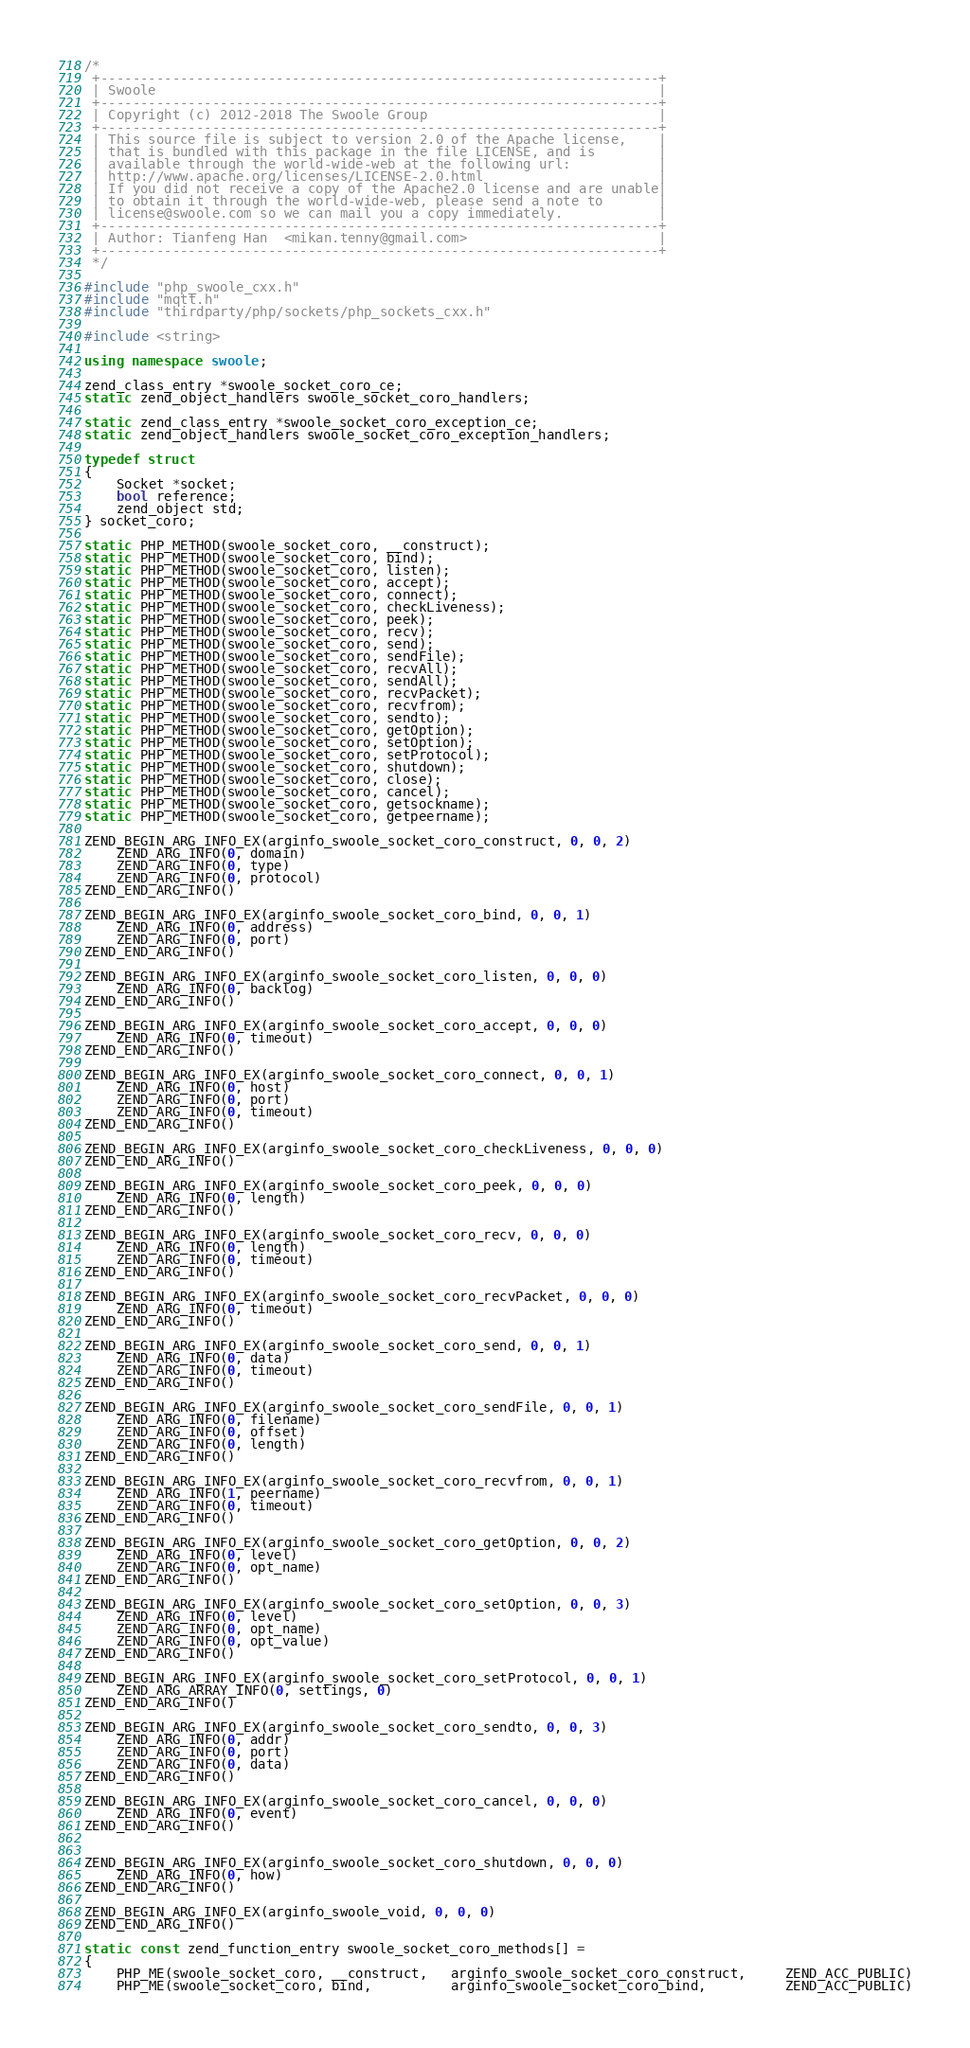<code> <loc_0><loc_0><loc_500><loc_500><_C++_>/*
 +----------------------------------------------------------------------+
 | Swoole                                                               |
 +----------------------------------------------------------------------+
 | Copyright (c) 2012-2018 The Swoole Group                             |
 +----------------------------------------------------------------------+
 | This source file is subject to version 2.0 of the Apache license,    |
 | that is bundled with this package in the file LICENSE, and is        |
 | available through the world-wide-web at the following url:           |
 | http://www.apache.org/licenses/LICENSE-2.0.html                      |
 | If you did not receive a copy of the Apache2.0 license and are unable|
 | to obtain it through the world-wide-web, please send a note to       |
 | license@swoole.com so we can mail you a copy immediately.            |
 +----------------------------------------------------------------------+
 | Author: Tianfeng Han  <mikan.tenny@gmail.com>                        |
 +----------------------------------------------------------------------+
 */

#include "php_swoole_cxx.h"
#include "mqtt.h"
#include "thirdparty/php/sockets/php_sockets_cxx.h"

#include <string>

using namespace swoole;

zend_class_entry *swoole_socket_coro_ce;
static zend_object_handlers swoole_socket_coro_handlers;

static zend_class_entry *swoole_socket_coro_exception_ce;
static zend_object_handlers swoole_socket_coro_exception_handlers;

typedef struct
{
    Socket *socket;
    bool reference;
    zend_object std;
} socket_coro;

static PHP_METHOD(swoole_socket_coro, __construct);
static PHP_METHOD(swoole_socket_coro, bind);
static PHP_METHOD(swoole_socket_coro, listen);
static PHP_METHOD(swoole_socket_coro, accept);
static PHP_METHOD(swoole_socket_coro, connect);
static PHP_METHOD(swoole_socket_coro, checkLiveness);
static PHP_METHOD(swoole_socket_coro, peek);
static PHP_METHOD(swoole_socket_coro, recv);
static PHP_METHOD(swoole_socket_coro, send);
static PHP_METHOD(swoole_socket_coro, sendFile);
static PHP_METHOD(swoole_socket_coro, recvAll);
static PHP_METHOD(swoole_socket_coro, sendAll);
static PHP_METHOD(swoole_socket_coro, recvPacket);
static PHP_METHOD(swoole_socket_coro, recvfrom);
static PHP_METHOD(swoole_socket_coro, sendto);
static PHP_METHOD(swoole_socket_coro, getOption);
static PHP_METHOD(swoole_socket_coro, setOption);
static PHP_METHOD(swoole_socket_coro, setProtocol);
static PHP_METHOD(swoole_socket_coro, shutdown);
static PHP_METHOD(swoole_socket_coro, close);
static PHP_METHOD(swoole_socket_coro, cancel);
static PHP_METHOD(swoole_socket_coro, getsockname);
static PHP_METHOD(swoole_socket_coro, getpeername);

ZEND_BEGIN_ARG_INFO_EX(arginfo_swoole_socket_coro_construct, 0, 0, 2)
    ZEND_ARG_INFO(0, domain)
    ZEND_ARG_INFO(0, type)
    ZEND_ARG_INFO(0, protocol)
ZEND_END_ARG_INFO()

ZEND_BEGIN_ARG_INFO_EX(arginfo_swoole_socket_coro_bind, 0, 0, 1)
    ZEND_ARG_INFO(0, address)
    ZEND_ARG_INFO(0, port)
ZEND_END_ARG_INFO()

ZEND_BEGIN_ARG_INFO_EX(arginfo_swoole_socket_coro_listen, 0, 0, 0)
    ZEND_ARG_INFO(0, backlog)
ZEND_END_ARG_INFO()

ZEND_BEGIN_ARG_INFO_EX(arginfo_swoole_socket_coro_accept, 0, 0, 0)
    ZEND_ARG_INFO(0, timeout)
ZEND_END_ARG_INFO()

ZEND_BEGIN_ARG_INFO_EX(arginfo_swoole_socket_coro_connect, 0, 0, 1)
    ZEND_ARG_INFO(0, host)
    ZEND_ARG_INFO(0, port)
    ZEND_ARG_INFO(0, timeout)
ZEND_END_ARG_INFO()

ZEND_BEGIN_ARG_INFO_EX(arginfo_swoole_socket_coro_checkLiveness, 0, 0, 0)
ZEND_END_ARG_INFO()

ZEND_BEGIN_ARG_INFO_EX(arginfo_swoole_socket_coro_peek, 0, 0, 0)
    ZEND_ARG_INFO(0, length)
ZEND_END_ARG_INFO()

ZEND_BEGIN_ARG_INFO_EX(arginfo_swoole_socket_coro_recv, 0, 0, 0)
    ZEND_ARG_INFO(0, length)
    ZEND_ARG_INFO(0, timeout)
ZEND_END_ARG_INFO()

ZEND_BEGIN_ARG_INFO_EX(arginfo_swoole_socket_coro_recvPacket, 0, 0, 0)
    ZEND_ARG_INFO(0, timeout)
ZEND_END_ARG_INFO()

ZEND_BEGIN_ARG_INFO_EX(arginfo_swoole_socket_coro_send, 0, 0, 1)
    ZEND_ARG_INFO(0, data)
    ZEND_ARG_INFO(0, timeout)
ZEND_END_ARG_INFO()

ZEND_BEGIN_ARG_INFO_EX(arginfo_swoole_socket_coro_sendFile, 0, 0, 1)
    ZEND_ARG_INFO(0, filename)
    ZEND_ARG_INFO(0, offset)
    ZEND_ARG_INFO(0, length)
ZEND_END_ARG_INFO()

ZEND_BEGIN_ARG_INFO_EX(arginfo_swoole_socket_coro_recvfrom, 0, 0, 1)
    ZEND_ARG_INFO(1, peername)
    ZEND_ARG_INFO(0, timeout)
ZEND_END_ARG_INFO()

ZEND_BEGIN_ARG_INFO_EX(arginfo_swoole_socket_coro_getOption, 0, 0, 2)
    ZEND_ARG_INFO(0, level)
    ZEND_ARG_INFO(0, opt_name)
ZEND_END_ARG_INFO()

ZEND_BEGIN_ARG_INFO_EX(arginfo_swoole_socket_coro_setOption, 0, 0, 3)
    ZEND_ARG_INFO(0, level)
    ZEND_ARG_INFO(0, opt_name)
    ZEND_ARG_INFO(0, opt_value)
ZEND_END_ARG_INFO()

ZEND_BEGIN_ARG_INFO_EX(arginfo_swoole_socket_coro_setProtocol, 0, 0, 1)
    ZEND_ARG_ARRAY_INFO(0, settings, 0)
ZEND_END_ARG_INFO()

ZEND_BEGIN_ARG_INFO_EX(arginfo_swoole_socket_coro_sendto, 0, 0, 3)
    ZEND_ARG_INFO(0, addr)
    ZEND_ARG_INFO(0, port)
    ZEND_ARG_INFO(0, data)
ZEND_END_ARG_INFO()

ZEND_BEGIN_ARG_INFO_EX(arginfo_swoole_socket_coro_cancel, 0, 0, 0)
    ZEND_ARG_INFO(0, event)
ZEND_END_ARG_INFO()


ZEND_BEGIN_ARG_INFO_EX(arginfo_swoole_socket_coro_shutdown, 0, 0, 0)
    ZEND_ARG_INFO(0, how)
ZEND_END_ARG_INFO()

ZEND_BEGIN_ARG_INFO_EX(arginfo_swoole_void, 0, 0, 0)
ZEND_END_ARG_INFO()

static const zend_function_entry swoole_socket_coro_methods[] =
{
    PHP_ME(swoole_socket_coro, __construct,   arginfo_swoole_socket_coro_construct,     ZEND_ACC_PUBLIC)
    PHP_ME(swoole_socket_coro, bind,          arginfo_swoole_socket_coro_bind,          ZEND_ACC_PUBLIC)</code> 